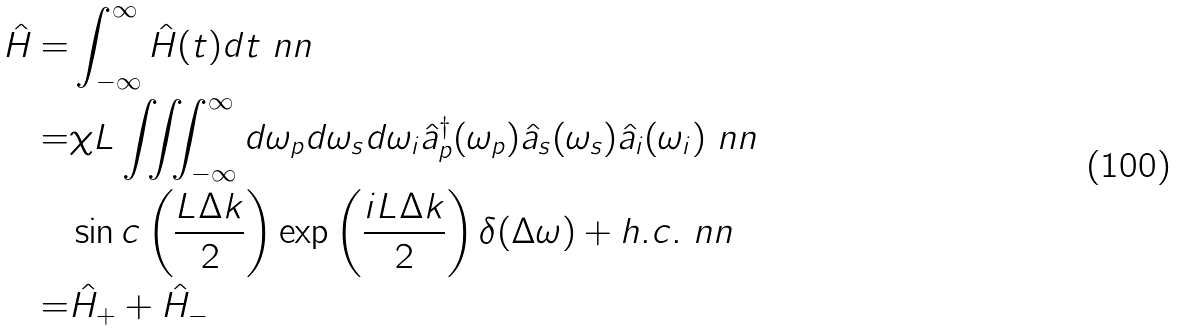<formula> <loc_0><loc_0><loc_500><loc_500>\hat { H } = & \int ^ { \infty } _ { - \infty } \hat { H } ( t ) d t \ n n \\ = & \chi L \iiint _ { - \infty } ^ { \infty } d \omega _ { p } d \omega _ { s } d \omega _ { i } \hat { a } _ { p } ^ { \dagger } ( \omega _ { p } ) \hat { a } _ { s } ( \omega _ { s } ) \hat { a } _ { i } ( \omega _ { i } ) \ n n \\ & \sin c \left ( \frac { L \Delta k } { 2 } \right ) \exp \left ( \frac { i L \Delta k } { 2 } \right ) \delta ( \Delta \omega ) + h . c . \ n n \\ = & \hat { H } _ { + } + \hat { H } _ { - }</formula> 